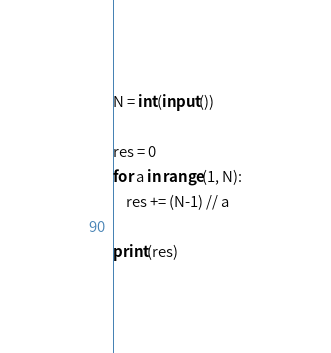Convert code to text. <code><loc_0><loc_0><loc_500><loc_500><_Python_>N = int(input())

res = 0
for a in range(1, N):
    res += (N-1) // a

print(res)</code> 